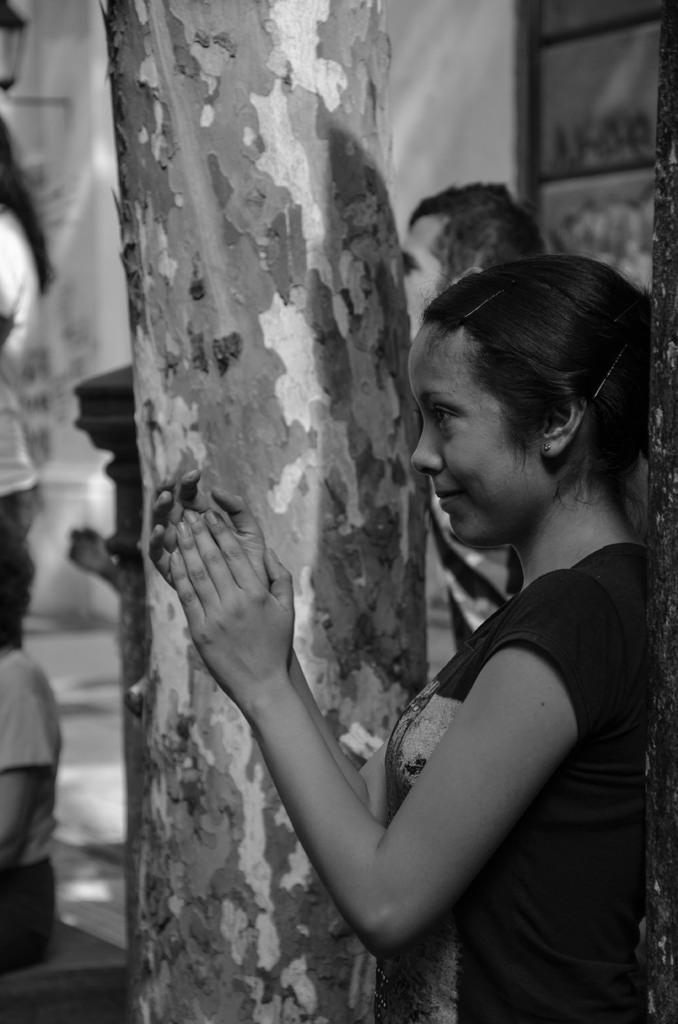What is the color scheme of the image? The image is black and white. What can be seen in the image besides the color scheme? There are persons, a tree, a window, and a wall in the image. How many flowers are visible in the image? There are no flowers present in the image. Can you describe the mist in the image? There is no mist present in the image. 